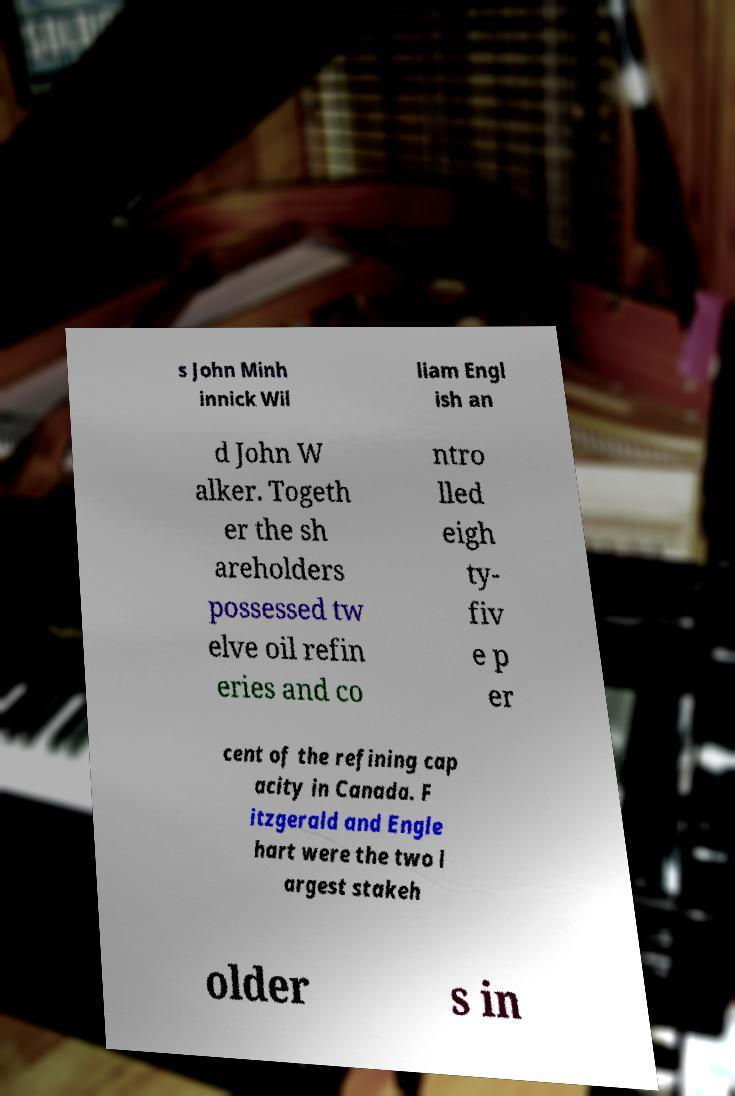Please identify and transcribe the text found in this image. s John Minh innick Wil liam Engl ish an d John W alker. Togeth er the sh areholders possessed tw elve oil refin eries and co ntro lled eigh ty- fiv e p er cent of the refining cap acity in Canada. F itzgerald and Engle hart were the two l argest stakeh older s in 